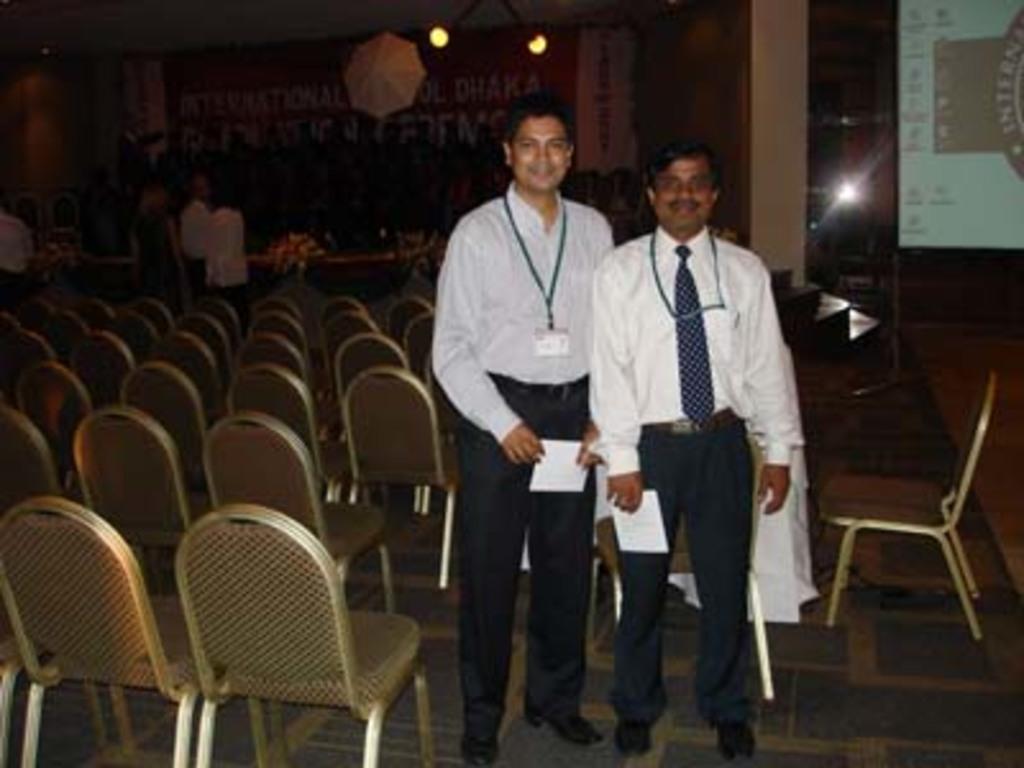In one or two sentences, can you explain what this image depicts? In the foreground of this picture, there are two men standing by holding a paper in their hands. In the background, there are chairs, persons standing, umbrella, lights, banner, stairs and a screen. 